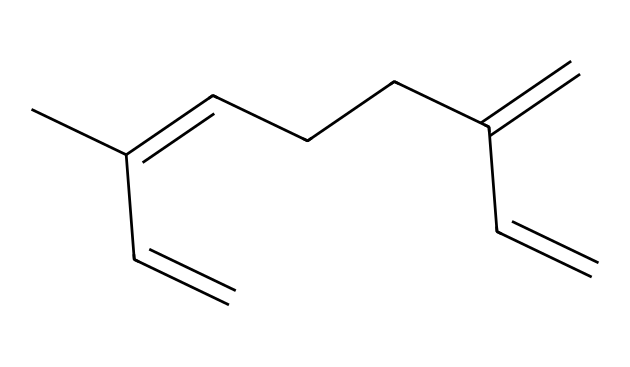What is the molecular formula of myrcene? By analyzing the SMILES representation, we see that it contains 10 carbon atoms (C) and 16 hydrogen atoms (H), which gives us the molecular formula C10H16.
Answer: C10H16 How many double bonds are present in myrcene? Looking at the structure represented in the SMILES, we see three double bonds indicated by the '=' signs in the chain.
Answer: 3 What type of reaction might myrcene undergo due to its double bonds? Myrcene, with multiple double bonds, is likely to undergo addition reactions, such as hydrogenation, where hydrogen can add across these double bonds.
Answer: addition Is myrcene a cyclic or acyclic compound? The SMILES representation indicates a linear chain of carbon atoms without any rings, thus classifying myrcene as acyclic.
Answer: acyclic What is the functional group present in myrcene? Myrcene does not have any functional groups such as alcohols or aldehydes, but it is classified as an alkene due to the presence of double bonds.
Answer: alkene How does the structure of myrcene compare to other terpenes? Myrcene has a specific linear structure with three double bonds, making it a monoterpene, and distinguishes itself from sesquiterpenes, which have larger structures.
Answer: monoterpene Which isomer of myrcene is most commonly found in nature? The most common isomer of myrcene found in nature is beta-myrcene, which is characterized by its particular arrangement of the double bonds in the carbon chain.
Answer: beta-myrcene 